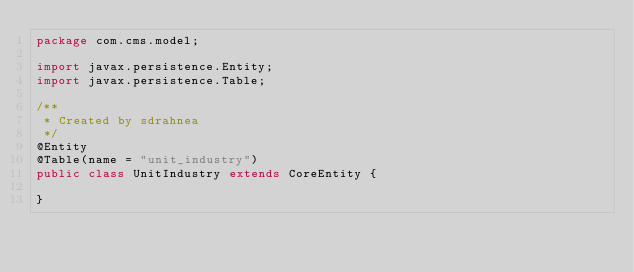Convert code to text. <code><loc_0><loc_0><loc_500><loc_500><_Java_>package com.cms.model;

import javax.persistence.Entity;
import javax.persistence.Table;

/**
 * Created by sdrahnea
 */
@Entity
@Table(name = "unit_industry")
public class UnitIndustry extends CoreEntity {

}
</code> 